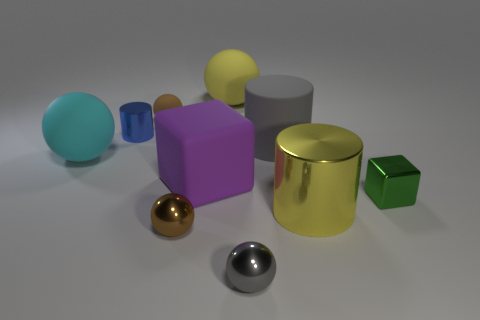Subtract all large cyan matte balls. How many balls are left? 4 Subtract all gray balls. How many balls are left? 4 Subtract all blue spheres. Subtract all gray blocks. How many spheres are left? 5 Subtract all cylinders. How many objects are left? 7 Add 6 yellow objects. How many yellow objects are left? 8 Add 2 small blue shiny blocks. How many small blue shiny blocks exist? 2 Subtract 0 purple cylinders. How many objects are left? 10 Subtract all blue cylinders. Subtract all tiny brown metal spheres. How many objects are left? 8 